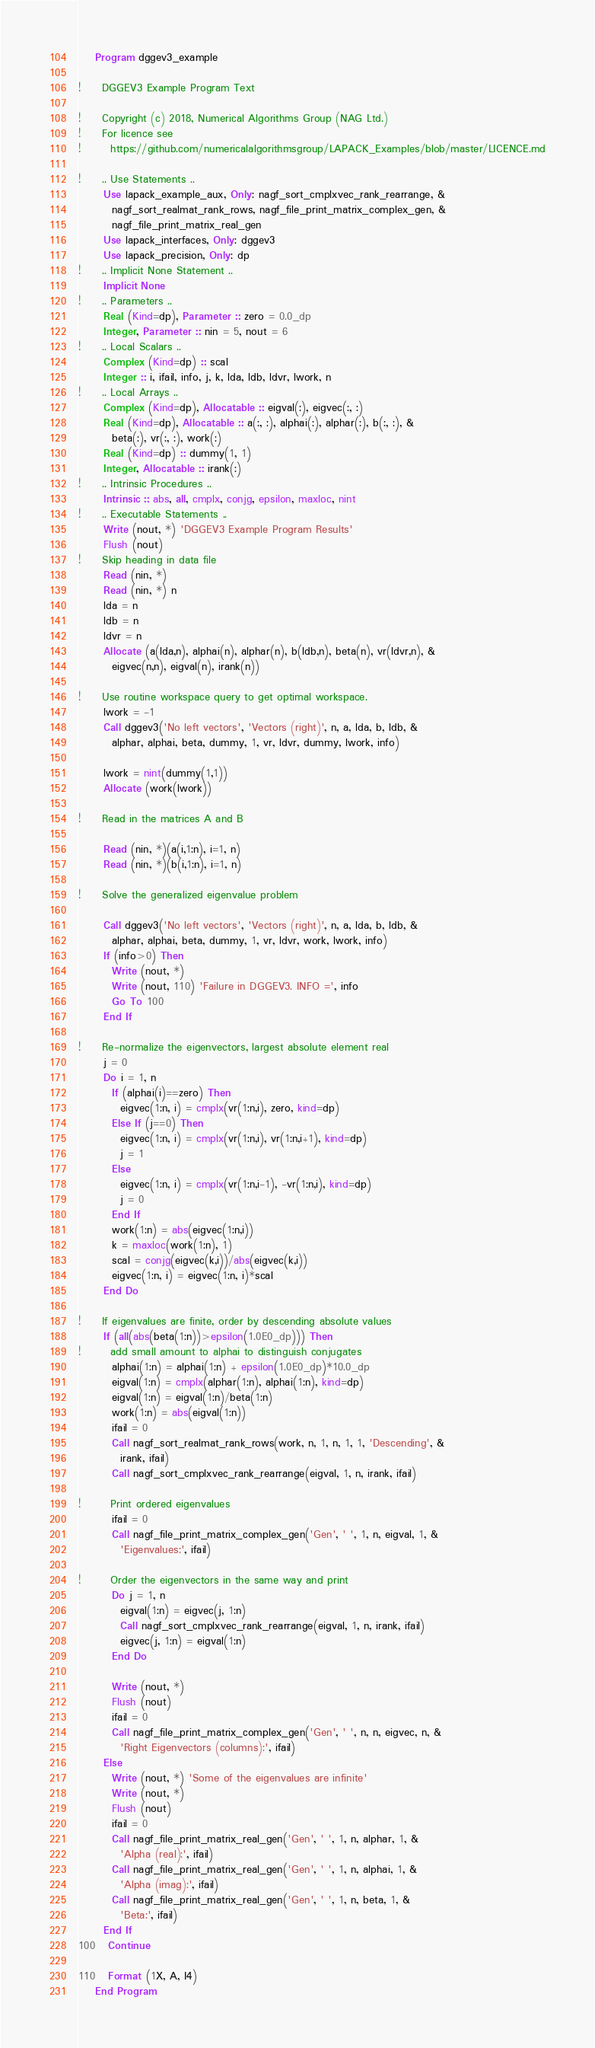<code> <loc_0><loc_0><loc_500><loc_500><_FORTRAN_>    Program dggev3_example

!     DGGEV3 Example Program Text

!     Copyright (c) 2018, Numerical Algorithms Group (NAG Ltd.)
!     For licence see
!       https://github.com/numericalalgorithmsgroup/LAPACK_Examples/blob/master/LICENCE.md

!     .. Use Statements ..
      Use lapack_example_aux, Only: nagf_sort_cmplxvec_rank_rearrange, &
        nagf_sort_realmat_rank_rows, nagf_file_print_matrix_complex_gen, &
        nagf_file_print_matrix_real_gen
      Use lapack_interfaces, Only: dggev3
      Use lapack_precision, Only: dp
!     .. Implicit None Statement ..
      Implicit None
!     .. Parameters ..
      Real (Kind=dp), Parameter :: zero = 0.0_dp
      Integer, Parameter :: nin = 5, nout = 6
!     .. Local Scalars ..
      Complex (Kind=dp) :: scal
      Integer :: i, ifail, info, j, k, lda, ldb, ldvr, lwork, n
!     .. Local Arrays ..
      Complex (Kind=dp), Allocatable :: eigval(:), eigvec(:, :)
      Real (Kind=dp), Allocatable :: a(:, :), alphai(:), alphar(:), b(:, :), &
        beta(:), vr(:, :), work(:)
      Real (Kind=dp) :: dummy(1, 1)
      Integer, Allocatable :: irank(:)
!     .. Intrinsic Procedures ..
      Intrinsic :: abs, all, cmplx, conjg, epsilon, maxloc, nint
!     .. Executable Statements ..
      Write (nout, *) 'DGGEV3 Example Program Results'
      Flush (nout)
!     Skip heading in data file
      Read (nin, *)
      Read (nin, *) n
      lda = n
      ldb = n
      ldvr = n
      Allocate (a(lda,n), alphai(n), alphar(n), b(ldb,n), beta(n), vr(ldvr,n), &
        eigvec(n,n), eigval(n), irank(n))

!     Use routine workspace query to get optimal workspace.
      lwork = -1
      Call dggev3('No left vectors', 'Vectors (right)', n, a, lda, b, ldb, &
        alphar, alphai, beta, dummy, 1, vr, ldvr, dummy, lwork, info)

      lwork = nint(dummy(1,1))
      Allocate (work(lwork))

!     Read in the matrices A and B

      Read (nin, *)(a(i,1:n), i=1, n)
      Read (nin, *)(b(i,1:n), i=1, n)

!     Solve the generalized eigenvalue problem

      Call dggev3('No left vectors', 'Vectors (right)', n, a, lda, b, ldb, &
        alphar, alphai, beta, dummy, 1, vr, ldvr, work, lwork, info)
      If (info>0) Then
        Write (nout, *)
        Write (nout, 110) 'Failure in DGGEV3. INFO =', info
        Go To 100
      End If

!     Re-normalize the eigenvectors, largest absolute element real
      j = 0
      Do i = 1, n
        If (alphai(i)==zero) Then
          eigvec(1:n, i) = cmplx(vr(1:n,i), zero, kind=dp)
        Else If (j==0) Then
          eigvec(1:n, i) = cmplx(vr(1:n,i), vr(1:n,i+1), kind=dp)
          j = 1
        Else
          eigvec(1:n, i) = cmplx(vr(1:n,i-1), -vr(1:n,i), kind=dp)
          j = 0
        End If
        work(1:n) = abs(eigvec(1:n,i))
        k = maxloc(work(1:n), 1)
        scal = conjg(eigvec(k,i))/abs(eigvec(k,i))
        eigvec(1:n, i) = eigvec(1:n, i)*scal
      End Do

!     If eigenvalues are finite, order by descending absolute values
      If (all(abs(beta(1:n))>epsilon(1.0E0_dp))) Then
!       add small amount to alphai to distinguish conjugates
        alphai(1:n) = alphai(1:n) + epsilon(1.0E0_dp)*10.0_dp
        eigval(1:n) = cmplx(alphar(1:n), alphai(1:n), kind=dp)
        eigval(1:n) = eigval(1:n)/beta(1:n)
        work(1:n) = abs(eigval(1:n))
        ifail = 0
        Call nagf_sort_realmat_rank_rows(work, n, 1, n, 1, 1, 'Descending', &
          irank, ifail)
        Call nagf_sort_cmplxvec_rank_rearrange(eigval, 1, n, irank, ifail)

!       Print ordered eigenvalues
        ifail = 0
        Call nagf_file_print_matrix_complex_gen('Gen', ' ', 1, n, eigval, 1, &
          'Eigenvalues:', ifail)

!       Order the eigenvectors in the same way and print
        Do j = 1, n
          eigval(1:n) = eigvec(j, 1:n)
          Call nagf_sort_cmplxvec_rank_rearrange(eigval, 1, n, irank, ifail)
          eigvec(j, 1:n) = eigval(1:n)
        End Do

        Write (nout, *)
        Flush (nout)
        ifail = 0
        Call nagf_file_print_matrix_complex_gen('Gen', ' ', n, n, eigvec, n, &
          'Right Eigenvectors (columns):', ifail)
      Else
        Write (nout, *) 'Some of the eigenvalues are infinite'
        Write (nout, *)
        Flush (nout)
        ifail = 0
        Call nagf_file_print_matrix_real_gen('Gen', ' ', 1, n, alphar, 1, &
          'Alpha (real):', ifail)
        Call nagf_file_print_matrix_real_gen('Gen', ' ', 1, n, alphai, 1, &
          'Alpha (imag):', ifail)
        Call nagf_file_print_matrix_real_gen('Gen', ' ', 1, n, beta, 1, &
          'Beta:', ifail)
      End If
100   Continue

110   Format (1X, A, I4)
    End Program
</code> 